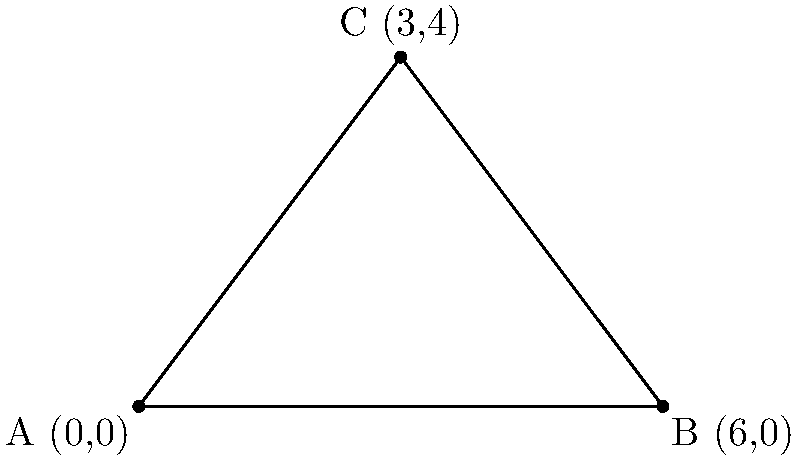As you plan the layout for your customer service call center, you decide to include a triangular break room. The room's corners are represented by the following coordinates: A(0,0), B(6,0), and C(3,4). Calculate the area of this triangular break room to ensure it meets the space requirements for your employees. To find the area of a triangle given three coordinate points, we can use the formula:

$$\text{Area} = \frac{1}{2}|x_1(y_2 - y_3) + x_2(y_3 - y_1) + x_3(y_1 - y_2)|$$

Where $(x_1, y_1)$, $(x_2, y_2)$, and $(x_3, y_3)$ are the coordinates of the three points.

Step 1: Identify the coordinates
A: $(x_1, y_1) = (0, 0)$
B: $(x_2, y_2) = (6, 0)$
C: $(x_3, y_3) = (3, 4)$

Step 2: Substitute the values into the formula
$$\text{Area} = \frac{1}{2}|0(0 - 4) + 6(4 - 0) + 3(0 - 0)|$$

Step 3: Simplify
$$\text{Area} = \frac{1}{2}|0 + 24 + 0|$$
$$\text{Area} = \frac{1}{2}(24)$$

Step 4: Calculate the final result
$$\text{Area} = 12$$

Therefore, the area of the triangular break room is 12 square units.
Answer: 12 square units 